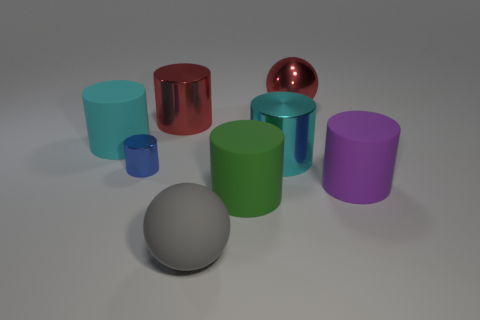Subtract all red cylinders. How many cylinders are left? 5 Add 1 red shiny balls. How many objects exist? 9 Subtract all purple balls. How many cyan cylinders are left? 2 Subtract all cyan cylinders. How many cylinders are left? 4 Subtract 2 cylinders. How many cylinders are left? 4 Subtract all cylinders. How many objects are left? 2 Add 8 tiny blue rubber cubes. How many tiny blue rubber cubes exist? 8 Subtract 0 blue cubes. How many objects are left? 8 Subtract all purple cylinders. Subtract all purple blocks. How many cylinders are left? 5 Subtract all red balls. Subtract all tiny gray balls. How many objects are left? 7 